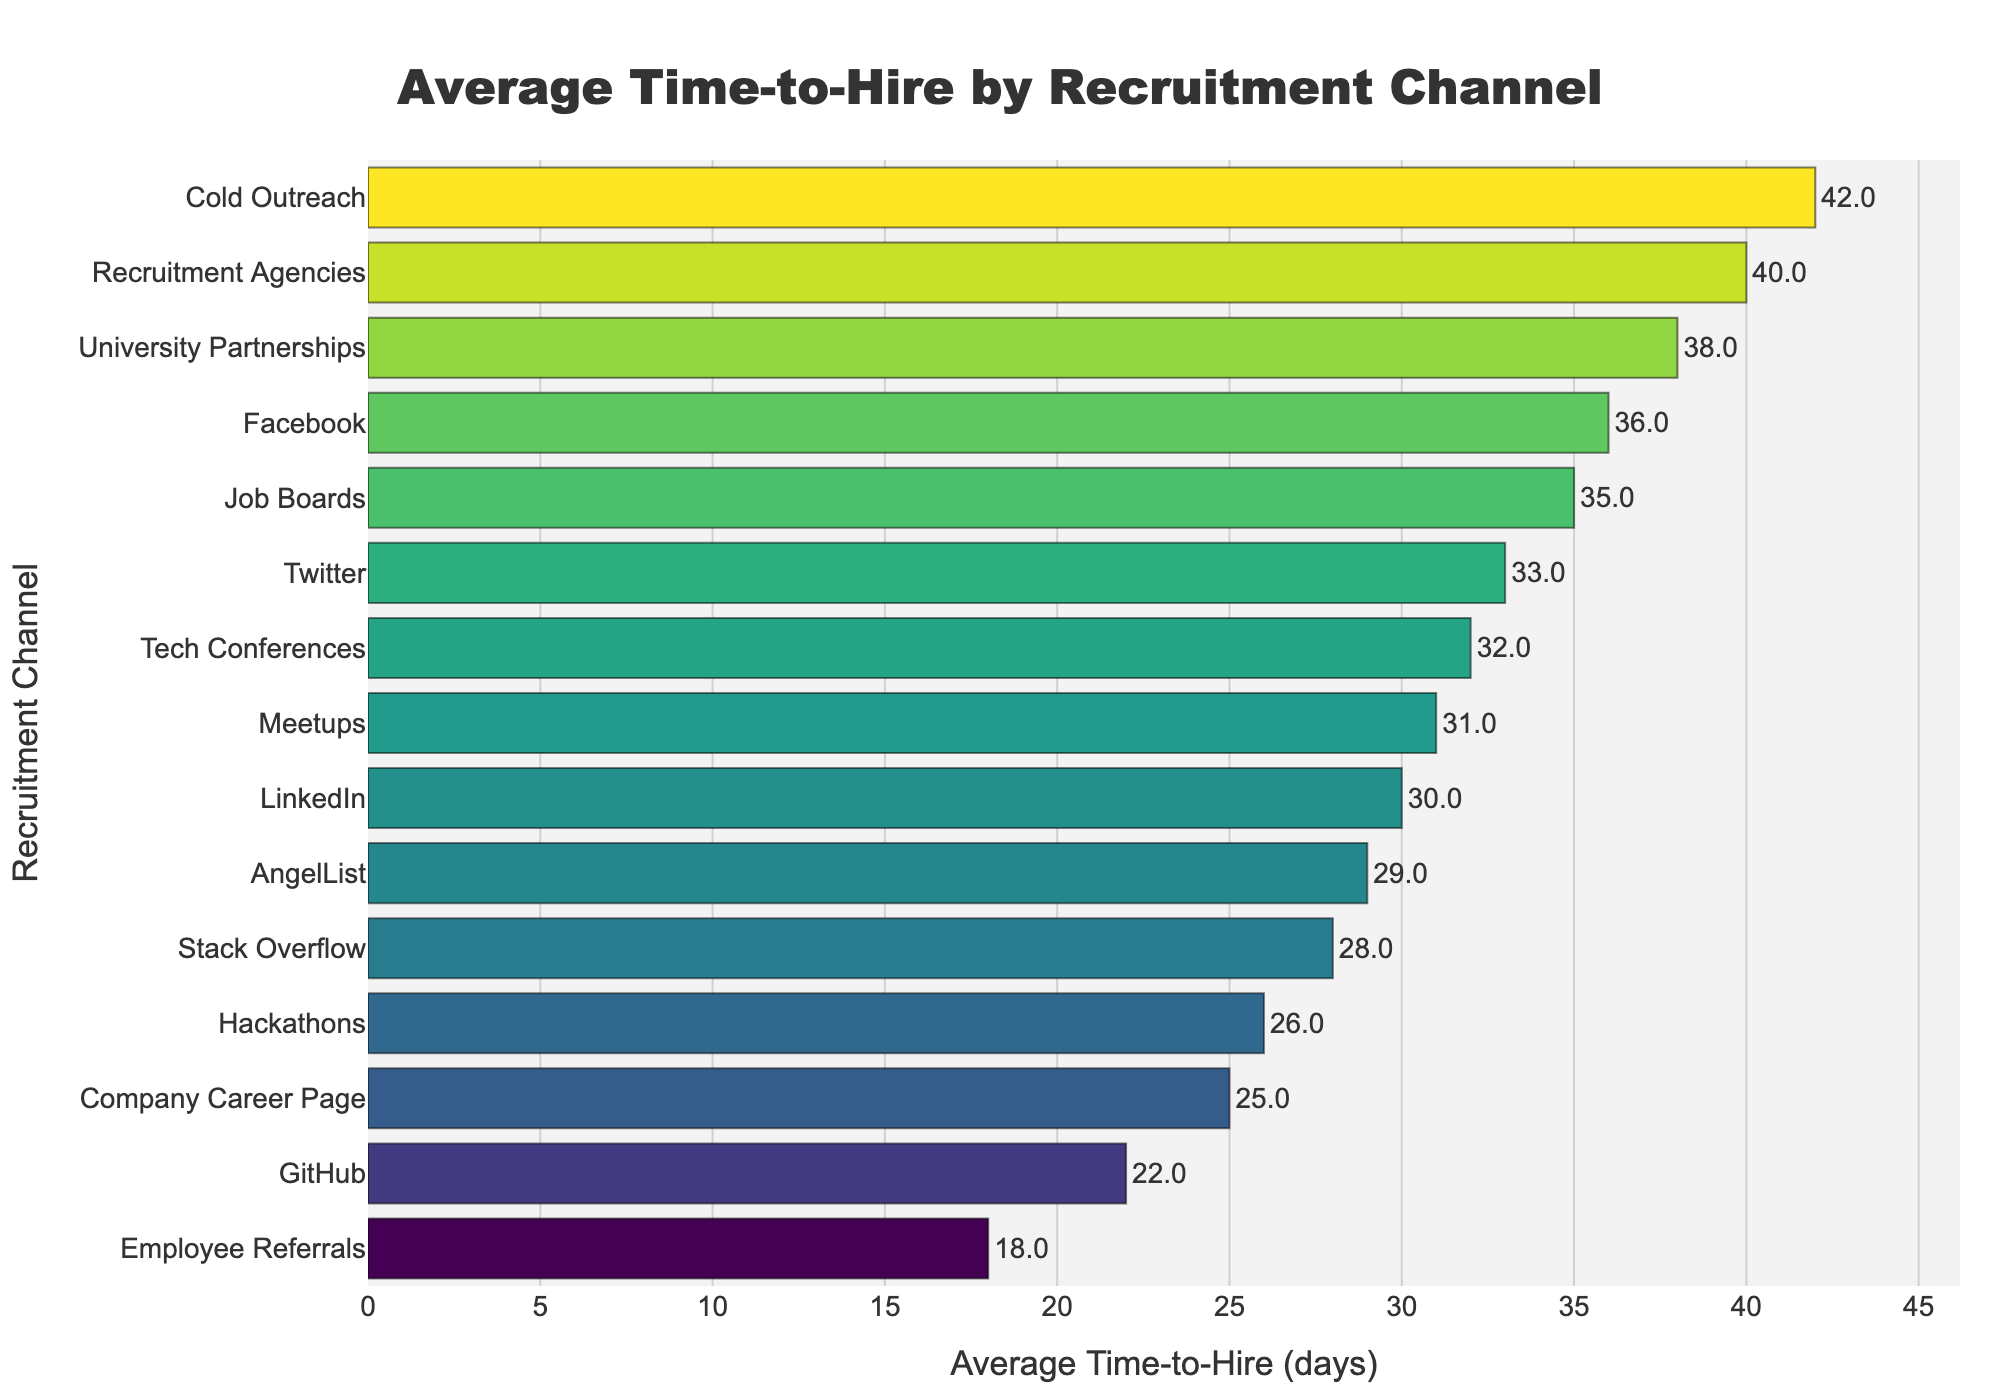What is the recruitment channel with the shortest average time-to-hire? By observing the chart, we can see that the bar with the shortest length corresponds to "Employee Referrals," which has the lowest value on the x-axis.
Answer: Employee Referrals Which recruitment channel has the longest average time-to-hire? By examining the chart, the bar corresponding to "Cold Outreach" reaches the farthest on the x-axis, indicating the highest value.
Answer: Cold Outreach How much longer is the average time-to-hire for Recruitment Agencies compared to Employee Referrals? The average time-to-hire for Recruitment Agencies is 40 days and for Employee Referrals is 18 days. The difference is 40 - 18 = 22 days.
Answer: 22 days What is the combined average time-to-hire for Tech Conferences, University Partnerships, and Facebook? The average time-to-hire values are Tech Conferences: 32 days, University Partnerships: 38 days, and Facebook: 36 days. The combined value is 32 + 38 + 36 = 106 days.
Answer: 106 days Which recruitment channel, LinkedIn or GitHub, has a shorter average time-to-hire, and by how many days? LinkedIn has an average time-to-hire of 30 days, and GitHub has 22 days. GitHub is shorter by 30 - 22 = 8 days.
Answer: GitHub, 8 days What is the average time-to-hire for the top 3 fastest recruitment channels? The top 3 fastest channels are Employee Referrals (18 days), GitHub (22 days), and Company Career Page (25 days). The average is (18 + 22 + 25) / 3 = 21.67 days.
Answer: 21.67 days Among Twitter, Meetups, and Stack Overflow, which one has the highest average time-to-hire? Observing the chart, Twitter has an average time-to-hire of 33 days, Meetups has 31 days, and Stack Overflow has 28 days. Thus, Twitter has the highest average time-to-hire.
Answer: Twitter Is the average time-to-hire for Company Career Page less than or equal to that of Hackathons? The chart shows that the average time-to-hire for Company Career Page is 25 days, and for Hackathons, it is 26 days. Since 25 is less than 26, the statement is true.
Answer: Yes What is the range of the average time-to-hire across all recruitment channels? The range is calculated by subtracting the smallest value (Employee Referrals: 18 days) from the largest value (Cold Outreach: 42 days). The range is 42 - 18 = 24 days.
Answer: 24 days How much greater is the average time-to-hire for Job Boards compared to GitHub? Job Boards have an average time-to-hire of 35 days, and GitHub has 22 days. Therefore, the difference is 35 - 22 = 13 days.
Answer: 13 days 